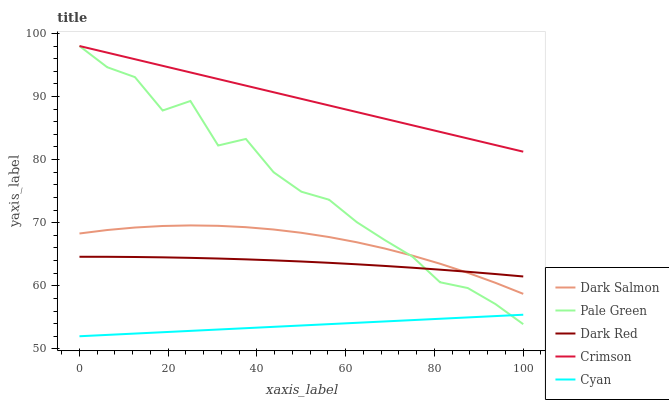Does Cyan have the minimum area under the curve?
Answer yes or no. Yes. Does Crimson have the maximum area under the curve?
Answer yes or no. Yes. Does Dark Red have the minimum area under the curve?
Answer yes or no. No. Does Dark Red have the maximum area under the curve?
Answer yes or no. No. Is Cyan the smoothest?
Answer yes or no. Yes. Is Pale Green the roughest?
Answer yes or no. Yes. Is Dark Red the smoothest?
Answer yes or no. No. Is Dark Red the roughest?
Answer yes or no. No. Does Cyan have the lowest value?
Answer yes or no. Yes. Does Dark Red have the lowest value?
Answer yes or no. No. Does Pale Green have the highest value?
Answer yes or no. Yes. Does Dark Red have the highest value?
Answer yes or no. No. Is Dark Salmon less than Crimson?
Answer yes or no. Yes. Is Crimson greater than Cyan?
Answer yes or no. Yes. Does Pale Green intersect Crimson?
Answer yes or no. Yes. Is Pale Green less than Crimson?
Answer yes or no. No. Is Pale Green greater than Crimson?
Answer yes or no. No. Does Dark Salmon intersect Crimson?
Answer yes or no. No. 